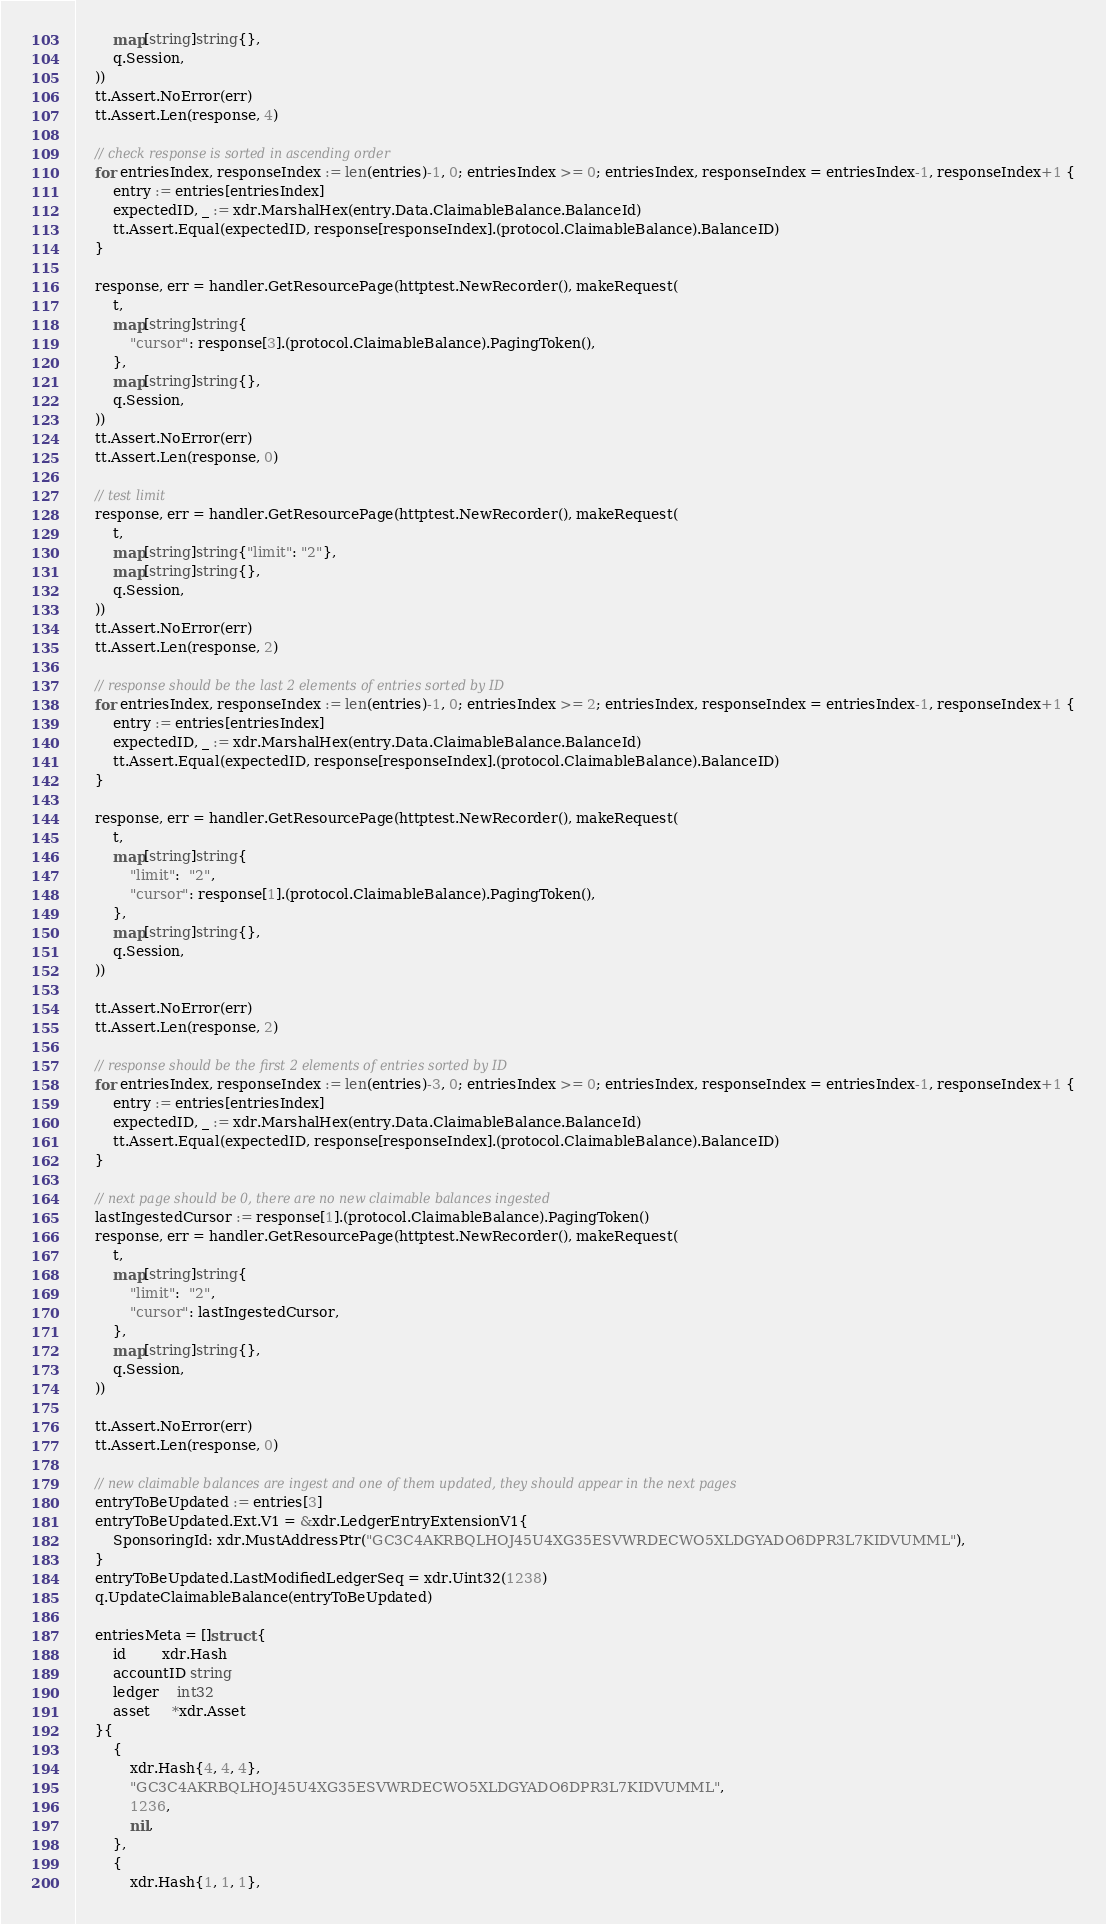Convert code to text. <code><loc_0><loc_0><loc_500><loc_500><_Go_>		map[string]string{},
		q.Session,
	))
	tt.Assert.NoError(err)
	tt.Assert.Len(response, 4)

	// check response is sorted in ascending order
	for entriesIndex, responseIndex := len(entries)-1, 0; entriesIndex >= 0; entriesIndex, responseIndex = entriesIndex-1, responseIndex+1 {
		entry := entries[entriesIndex]
		expectedID, _ := xdr.MarshalHex(entry.Data.ClaimableBalance.BalanceId)
		tt.Assert.Equal(expectedID, response[responseIndex].(protocol.ClaimableBalance).BalanceID)
	}

	response, err = handler.GetResourcePage(httptest.NewRecorder(), makeRequest(
		t,
		map[string]string{
			"cursor": response[3].(protocol.ClaimableBalance).PagingToken(),
		},
		map[string]string{},
		q.Session,
	))
	tt.Assert.NoError(err)
	tt.Assert.Len(response, 0)

	// test limit
	response, err = handler.GetResourcePage(httptest.NewRecorder(), makeRequest(
		t,
		map[string]string{"limit": "2"},
		map[string]string{},
		q.Session,
	))
	tt.Assert.NoError(err)
	tt.Assert.Len(response, 2)

	// response should be the last 2 elements of entries sorted by ID
	for entriesIndex, responseIndex := len(entries)-1, 0; entriesIndex >= 2; entriesIndex, responseIndex = entriesIndex-1, responseIndex+1 {
		entry := entries[entriesIndex]
		expectedID, _ := xdr.MarshalHex(entry.Data.ClaimableBalance.BalanceId)
		tt.Assert.Equal(expectedID, response[responseIndex].(protocol.ClaimableBalance).BalanceID)
	}

	response, err = handler.GetResourcePage(httptest.NewRecorder(), makeRequest(
		t,
		map[string]string{
			"limit":  "2",
			"cursor": response[1].(protocol.ClaimableBalance).PagingToken(),
		},
		map[string]string{},
		q.Session,
	))

	tt.Assert.NoError(err)
	tt.Assert.Len(response, 2)

	// response should be the first 2 elements of entries sorted by ID
	for entriesIndex, responseIndex := len(entries)-3, 0; entriesIndex >= 0; entriesIndex, responseIndex = entriesIndex-1, responseIndex+1 {
		entry := entries[entriesIndex]
		expectedID, _ := xdr.MarshalHex(entry.Data.ClaimableBalance.BalanceId)
		tt.Assert.Equal(expectedID, response[responseIndex].(protocol.ClaimableBalance).BalanceID)
	}

	// next page should be 0, there are no new claimable balances ingested
	lastIngestedCursor := response[1].(protocol.ClaimableBalance).PagingToken()
	response, err = handler.GetResourcePage(httptest.NewRecorder(), makeRequest(
		t,
		map[string]string{
			"limit":  "2",
			"cursor": lastIngestedCursor,
		},
		map[string]string{},
		q.Session,
	))

	tt.Assert.NoError(err)
	tt.Assert.Len(response, 0)

	// new claimable balances are ingest and one of them updated, they should appear in the next pages
	entryToBeUpdated := entries[3]
	entryToBeUpdated.Ext.V1 = &xdr.LedgerEntryExtensionV1{
		SponsoringId: xdr.MustAddressPtr("GC3C4AKRBQLHOJ45U4XG35ESVWRDECWO5XLDGYADO6DPR3L7KIDVUMML"),
	}
	entryToBeUpdated.LastModifiedLedgerSeq = xdr.Uint32(1238)
	q.UpdateClaimableBalance(entryToBeUpdated)

	entriesMeta = []struct {
		id        xdr.Hash
		accountID string
		ledger    int32
		asset     *xdr.Asset
	}{
		{
			xdr.Hash{4, 4, 4},
			"GC3C4AKRBQLHOJ45U4XG35ESVWRDECWO5XLDGYADO6DPR3L7KIDVUMML",
			1236,
			nil,
		},
		{
			xdr.Hash{1, 1, 1},</code> 